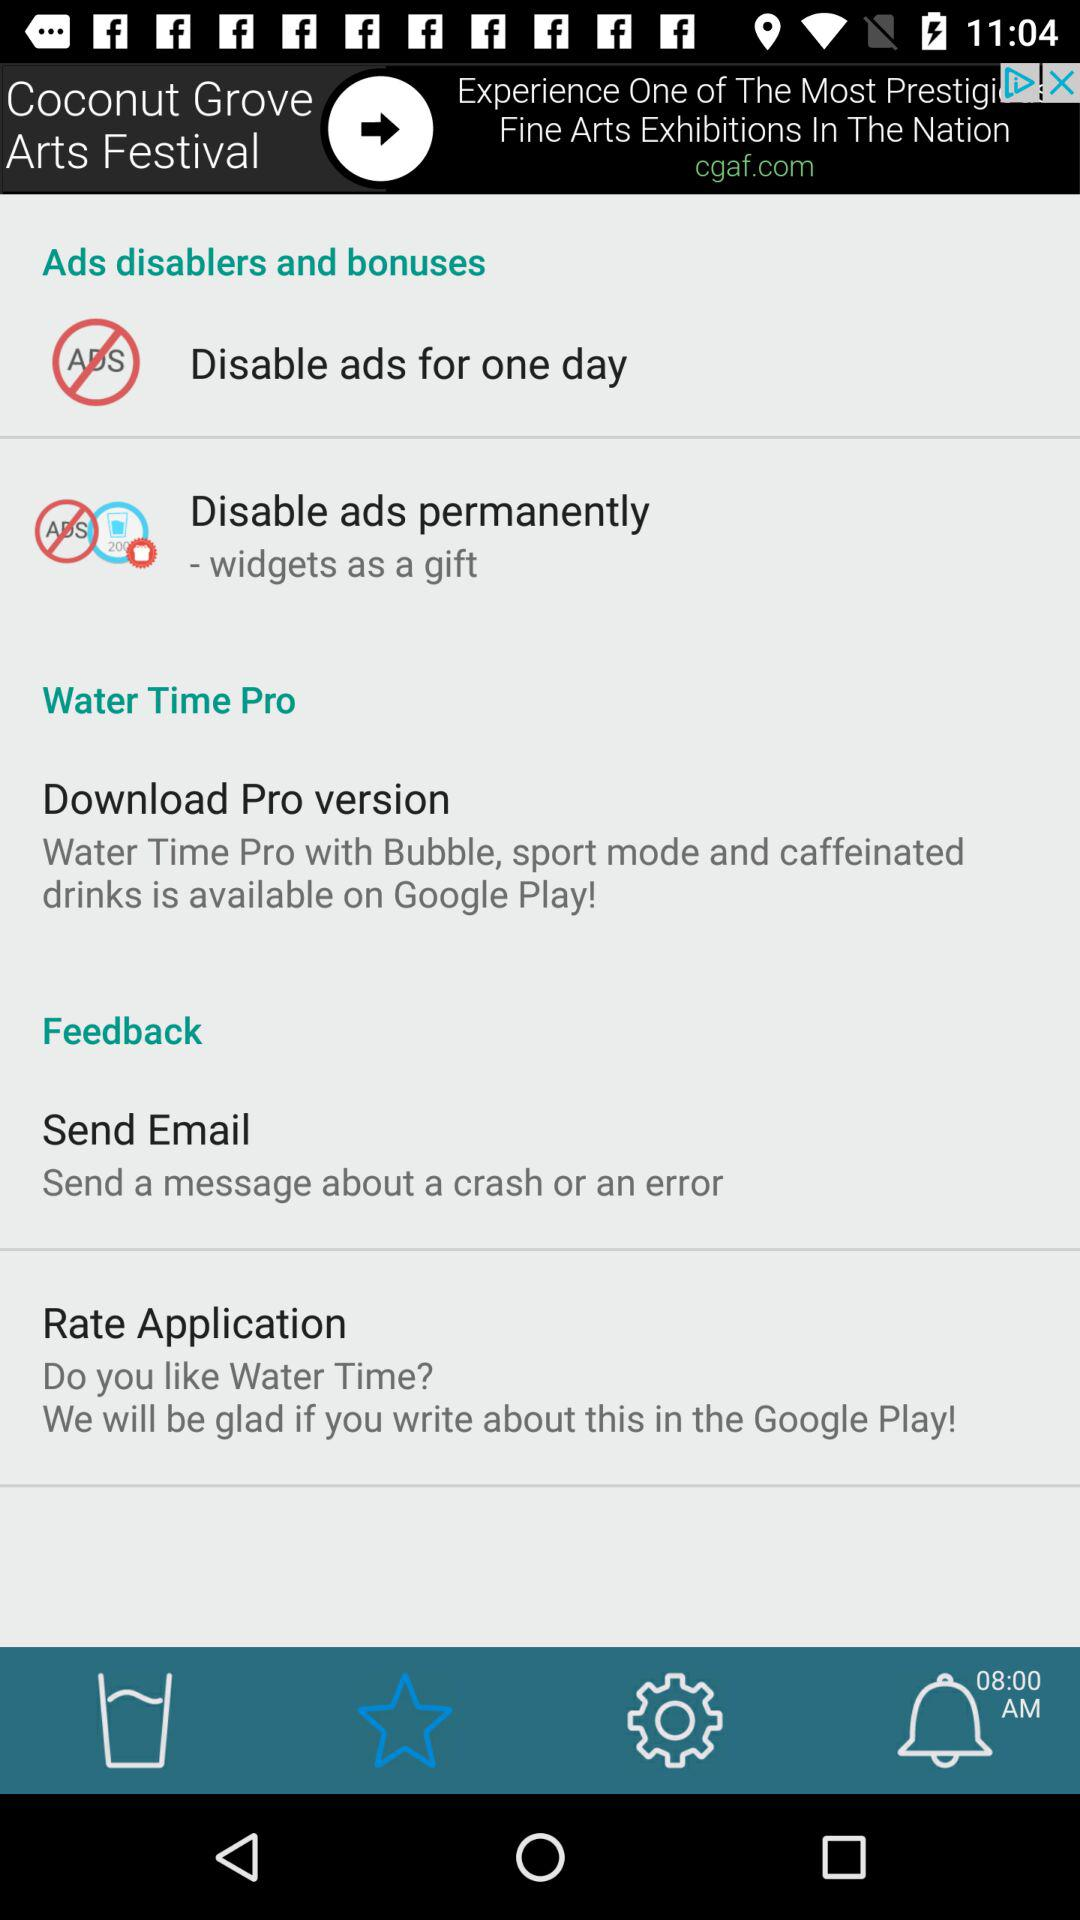What are Ads disablers and bonuses?
When the provided information is insufficient, respond with <no answer>. <no answer> 